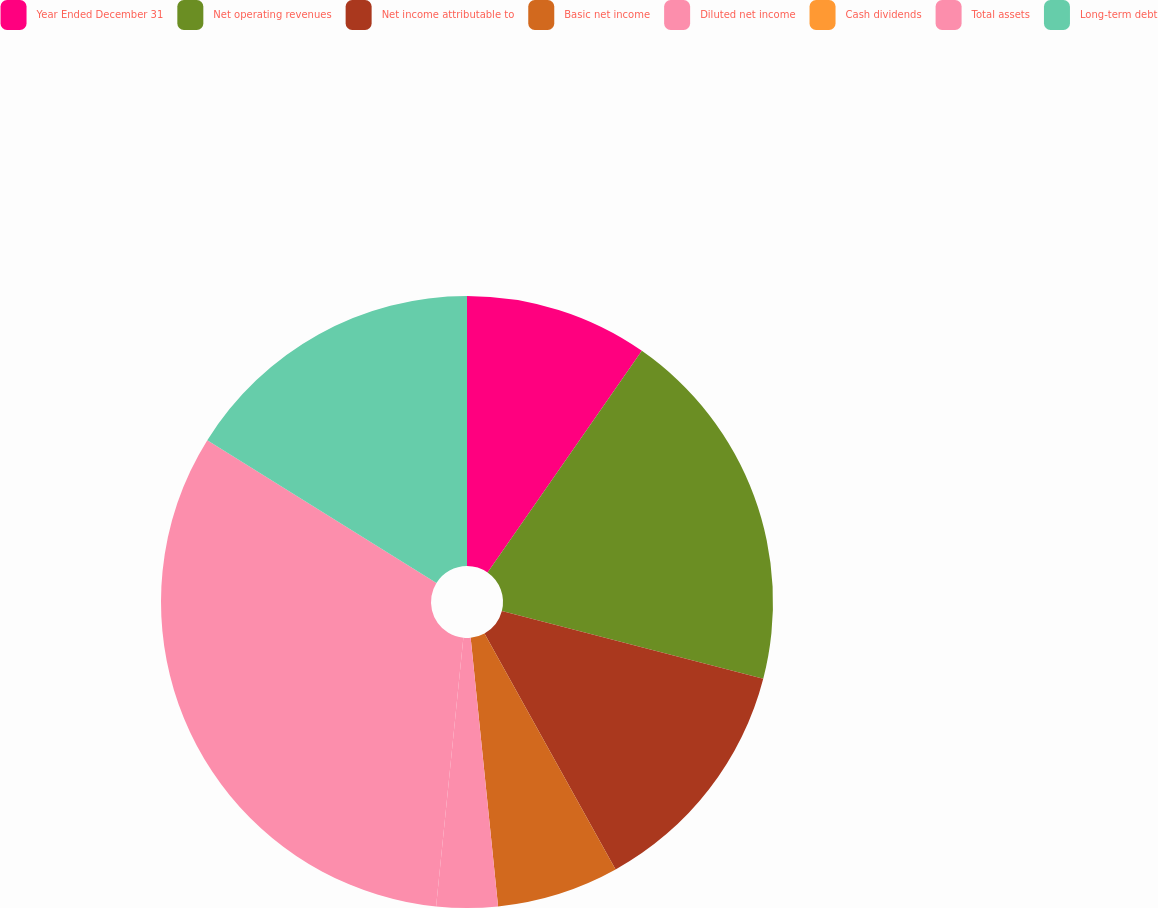Convert chart. <chart><loc_0><loc_0><loc_500><loc_500><pie_chart><fcel>Year Ended December 31<fcel>Net operating revenues<fcel>Net income attributable to<fcel>Basic net income<fcel>Diluted net income<fcel>Cash dividends<fcel>Total assets<fcel>Long-term debt<nl><fcel>9.68%<fcel>19.35%<fcel>12.9%<fcel>6.45%<fcel>3.23%<fcel>0.0%<fcel>32.26%<fcel>16.13%<nl></chart> 